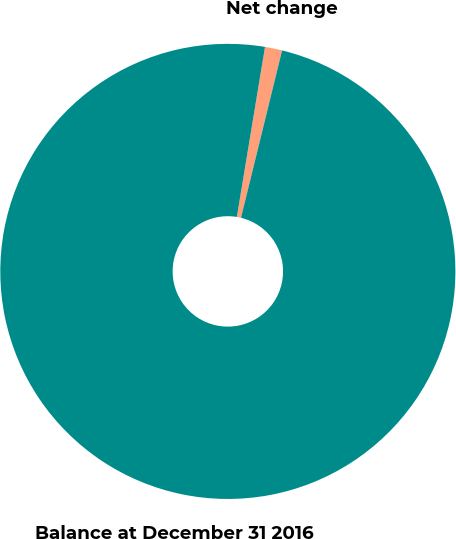Convert chart to OTSL. <chart><loc_0><loc_0><loc_500><loc_500><pie_chart><fcel>Net change<fcel>Balance at December 31 2016<nl><fcel>1.22%<fcel>98.78%<nl></chart> 